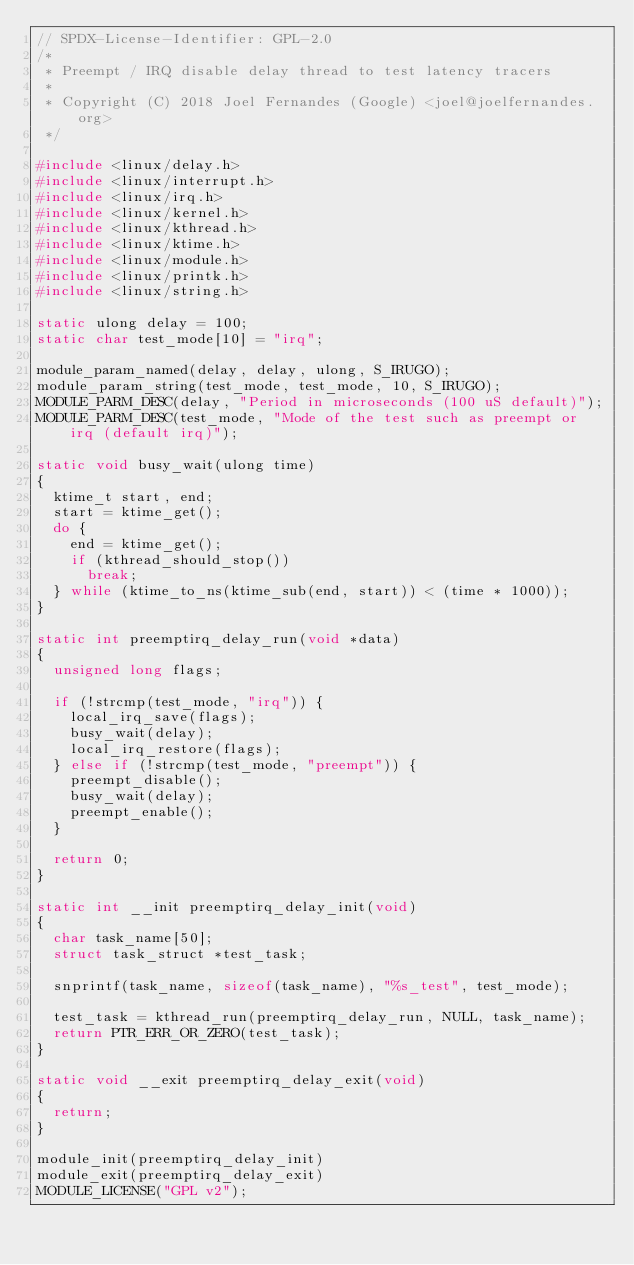<code> <loc_0><loc_0><loc_500><loc_500><_C_>// SPDX-License-Identifier: GPL-2.0
/*
 * Preempt / IRQ disable delay thread to test latency tracers
 *
 * Copyright (C) 2018 Joel Fernandes (Google) <joel@joelfernandes.org>
 */

#include <linux/delay.h>
#include <linux/interrupt.h>
#include <linux/irq.h>
#include <linux/kernel.h>
#include <linux/kthread.h>
#include <linux/ktime.h>
#include <linux/module.h>
#include <linux/printk.h>
#include <linux/string.h>

static ulong delay = 100;
static char test_mode[10] = "irq";

module_param_named(delay, delay, ulong, S_IRUGO);
module_param_string(test_mode, test_mode, 10, S_IRUGO);
MODULE_PARM_DESC(delay, "Period in microseconds (100 uS default)");
MODULE_PARM_DESC(test_mode, "Mode of the test such as preempt or irq (default irq)");

static void busy_wait(ulong time)
{
	ktime_t start, end;
	start = ktime_get();
	do {
		end = ktime_get();
		if (kthread_should_stop())
			break;
	} while (ktime_to_ns(ktime_sub(end, start)) < (time * 1000));
}

static int preemptirq_delay_run(void *data)
{
	unsigned long flags;

	if (!strcmp(test_mode, "irq")) {
		local_irq_save(flags);
		busy_wait(delay);
		local_irq_restore(flags);
	} else if (!strcmp(test_mode, "preempt")) {
		preempt_disable();
		busy_wait(delay);
		preempt_enable();
	}

	return 0;
}

static int __init preemptirq_delay_init(void)
{
	char task_name[50];
	struct task_struct *test_task;

	snprintf(task_name, sizeof(task_name), "%s_test", test_mode);

	test_task = kthread_run(preemptirq_delay_run, NULL, task_name);
	return PTR_ERR_OR_ZERO(test_task);
}

static void __exit preemptirq_delay_exit(void)
{
	return;
}

module_init(preemptirq_delay_init)
module_exit(preemptirq_delay_exit)
MODULE_LICENSE("GPL v2");
</code> 